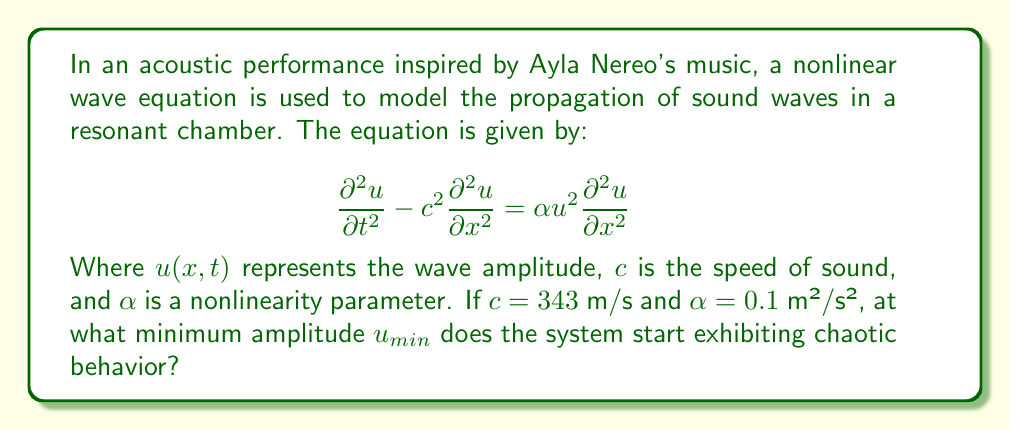Give your solution to this math problem. To determine the onset of chaotic behavior in this nonlinear acoustic system, we need to analyze the balance between the linear and nonlinear terms in the wave equation.

Step 1: Identify the linear and nonlinear terms
Linear term: $c^2\frac{\partial^2 u}{\partial x^2}$
Nonlinear term: $\alpha u^2\frac{\partial^2 u}{\partial x^2}$

Step 2: Determine when the nonlinear term becomes significant
The system starts to exhibit chaotic behavior when the nonlinear term is of the same order of magnitude as the linear term. We can express this condition as:

$$c^2 \approx \alpha u_{min}^2$$

Step 3: Solve for $u_{min}$
Rearranging the equation:

$$u_{min}^2 \approx \frac{c^2}{\alpha}$$

$$u_{min} \approx \sqrt{\frac{c^2}{\alpha}}$$

Step 4: Substitute the given values
$c = 343$ m/s
$\alpha = 0.1$ m²/s²

$$u_{min} \approx \sqrt{\frac{(343\text{ m/s})^2}{0.1\text{ m²/s²}}}$$

Step 5: Calculate the result

$$u_{min} \approx \sqrt{\frac{117649}{0.1}} \approx \sqrt{1176490} \approx 1084.66\text{ m}$$

Therefore, the system starts exhibiting chaotic behavior when the wave amplitude reaches approximately 1084.66 meters.
Answer: $u_{min} \approx 1084.66\text{ m}$ 